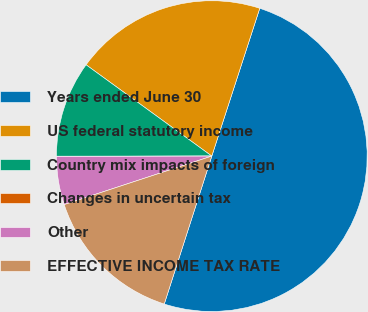Convert chart to OTSL. <chart><loc_0><loc_0><loc_500><loc_500><pie_chart><fcel>Years ended June 30<fcel>US federal statutory income<fcel>Country mix impacts of foreign<fcel>Changes in uncertain tax<fcel>Other<fcel>EFFECTIVE INCOME TAX RATE<nl><fcel>49.96%<fcel>20.0%<fcel>10.01%<fcel>0.02%<fcel>5.02%<fcel>15.0%<nl></chart> 